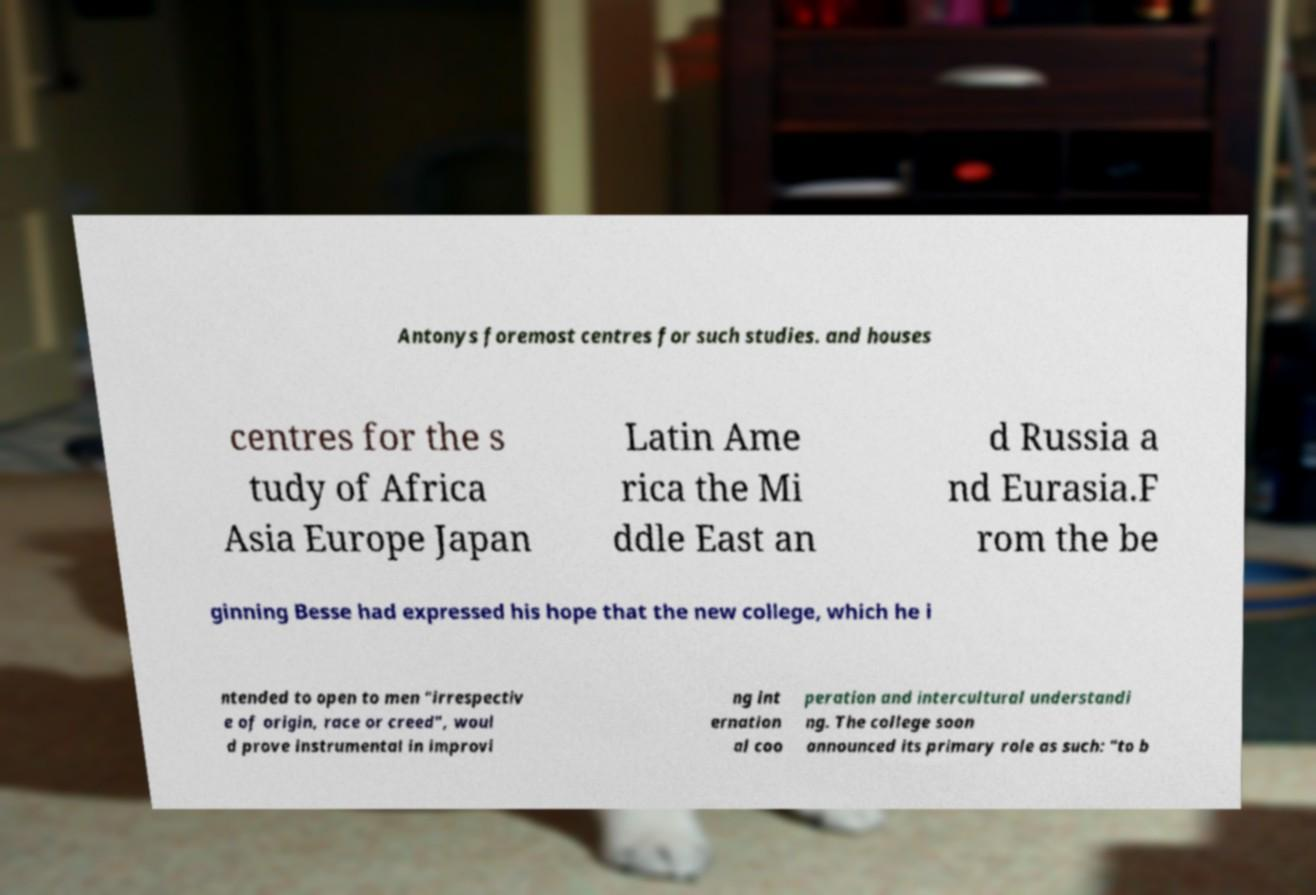Can you read and provide the text displayed in the image?This photo seems to have some interesting text. Can you extract and type it out for me? Antonys foremost centres for such studies. and houses centres for the s tudy of Africa Asia Europe Japan Latin Ame rica the Mi ddle East an d Russia a nd Eurasia.F rom the be ginning Besse had expressed his hope that the new college, which he i ntended to open to men "irrespectiv e of origin, race or creed", woul d prove instrumental in improvi ng int ernation al coo peration and intercultural understandi ng. The college soon announced its primary role as such: "to b 